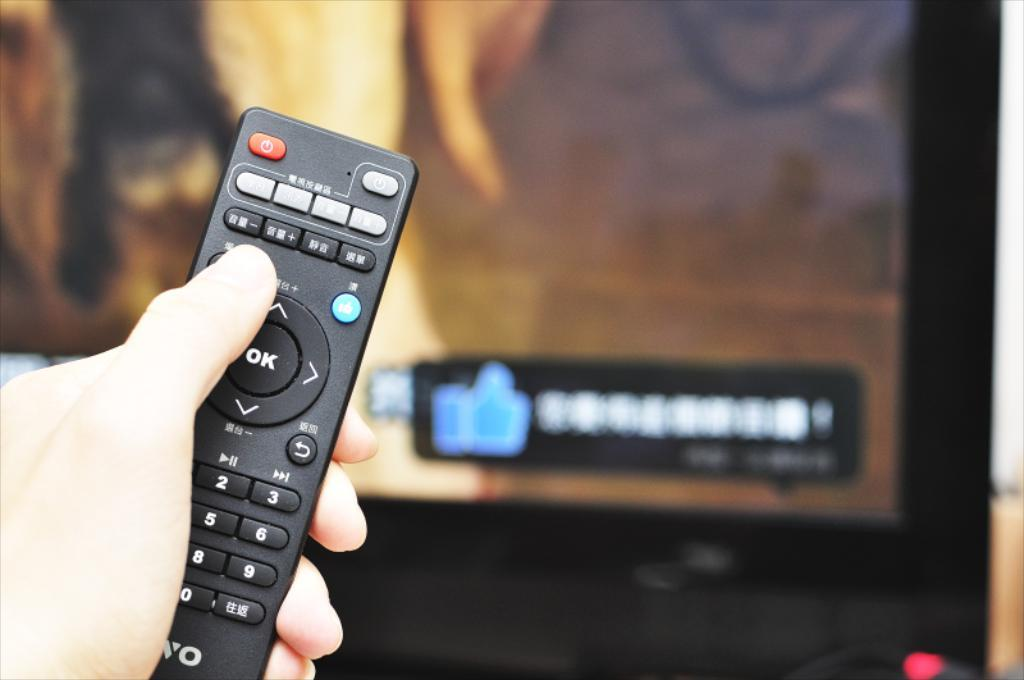What is the main object being held in the image? There is a hand holding a remote in the image. Can you describe the appearance of the remote? The background of the remote is blurred. What type of straw is used to make the jam in the image? There is no straw or jam present in the image; it only features a hand holding a remote. 